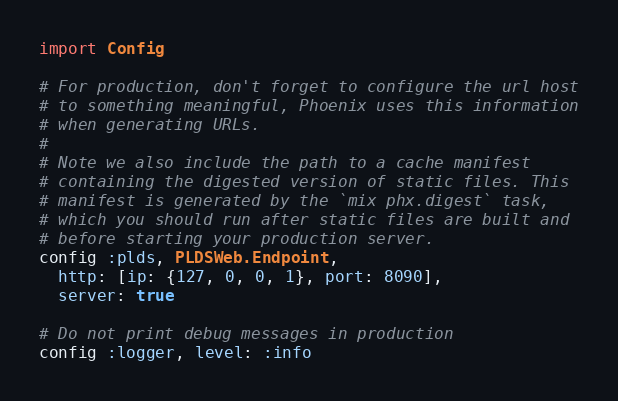<code> <loc_0><loc_0><loc_500><loc_500><_Elixir_>import Config

# For production, don't forget to configure the url host
# to something meaningful, Phoenix uses this information
# when generating URLs.
#
# Note we also include the path to a cache manifest
# containing the digested version of static files. This
# manifest is generated by the `mix phx.digest` task,
# which you should run after static files are built and
# before starting your production server.
config :plds, PLDSWeb.Endpoint,
  http: [ip: {127, 0, 0, 1}, port: 8090],
  server: true

# Do not print debug messages in production
config :logger, level: :info
</code> 